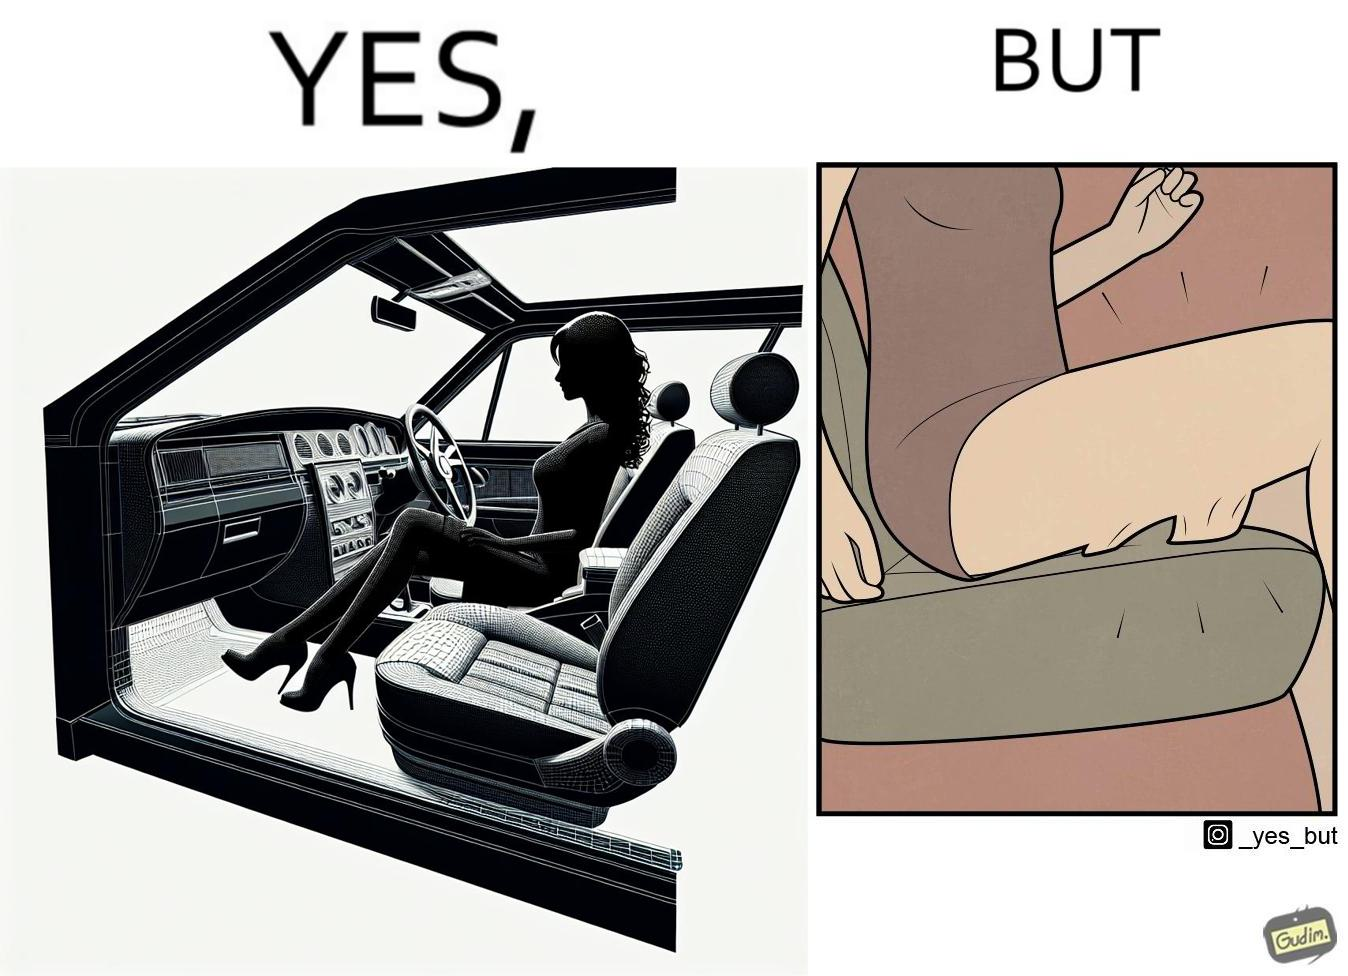Describe the content of this image. The image is ironic, because the woman is wearing a short dress to look stylish but she had to face inconvenience while travelling in car due to her short dress only. 